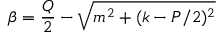Convert formula to latex. <formula><loc_0><loc_0><loc_500><loc_500>\beta = \frac { Q } { 2 } - \sqrt { m ^ { 2 } + ( k - P / 2 ) ^ { 2 } }</formula> 